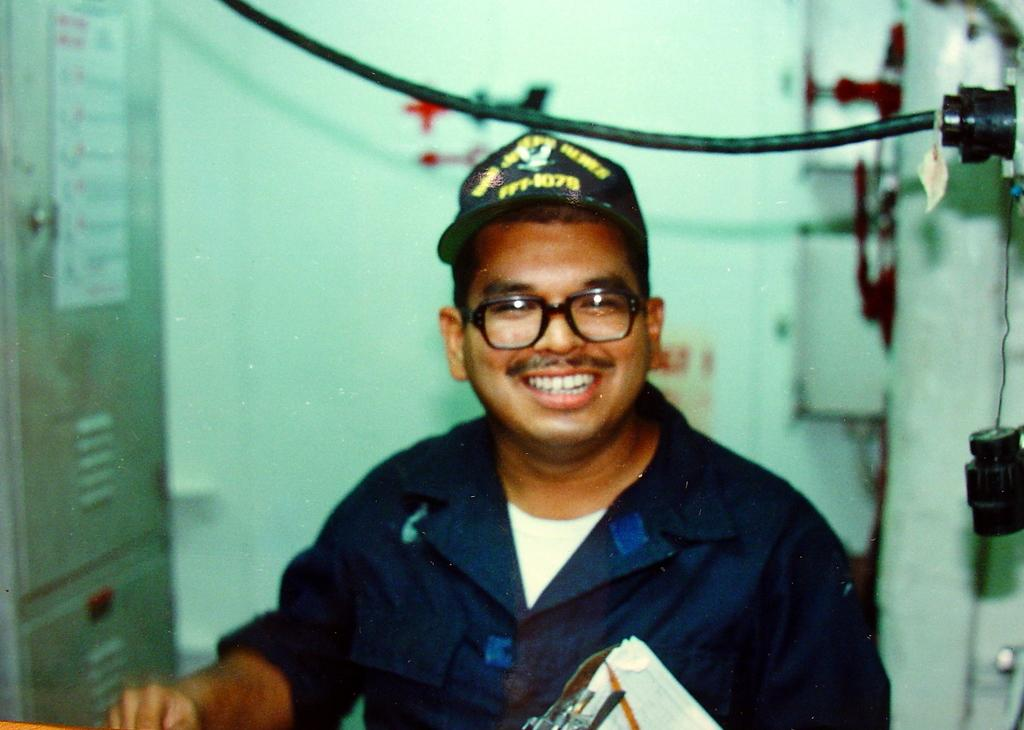What is the facial expression of the person in the image? The person in the image is smiling. What type of headwear is the person wearing? The person is wearing a cap. What type of eyewear is the person wearing? The person is wearing spectacles. Can you describe the background of the image? The background of the image is blurred, and there are cupboards, a cable, a wall, boxes, and a board on one of the cupboards visible. What type of care is the person providing in the image? There is no indication of care being provided in the image; the person is simply smiling and wearing a cap and spectacles. Is the person engaged in a fight in the image? No, the person is not engaged in a fight in the image; they are smiling and there is no indication of any conflict. 